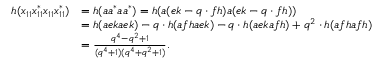Convert formula to latex. <formula><loc_0><loc_0><loc_500><loc_500>\begin{array} { r l } { h ( x _ { 1 1 } x _ { 1 1 } ^ { * } x _ { 1 1 } x _ { 1 1 } ^ { * } ) } & { = h ( a a ^ { * } a a ^ { * } ) = h ( a ( e k - q \cdot f h ) a ( e k - q \cdot f h ) ) } \\ & { = h ( a e k a e k ) - q \cdot h ( a f h a e k ) - q \cdot h ( a e k a f h ) + q ^ { 2 } \cdot h ( a f h a f h ) } \\ & { = \frac { q ^ { 4 } - q ^ { 2 } + 1 } { ( q ^ { 4 } + 1 ) ( q ^ { 4 } + q ^ { 2 } + 1 ) } . } \end{array}</formula> 